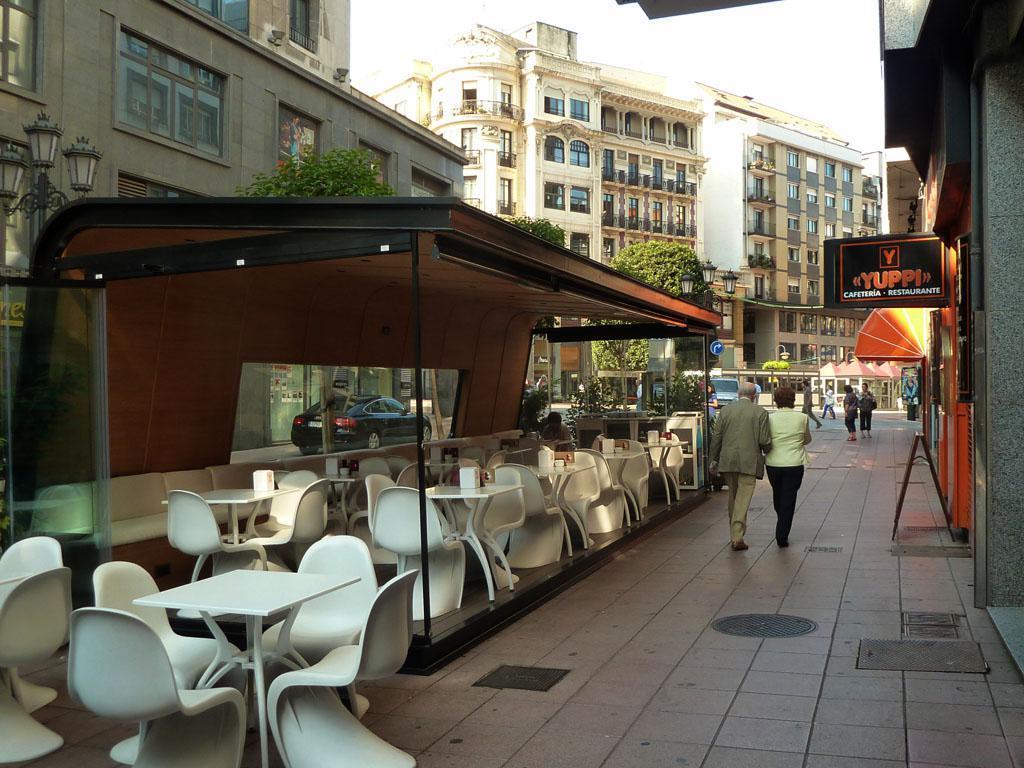How would you summarize this image in a sentence or two? In the picture I can see there are few people walking on the road, I can see white color tables, white color chairs, I can see boards, light poles, trees, vehicles on the road, I can see buildings and the sky in the background. 